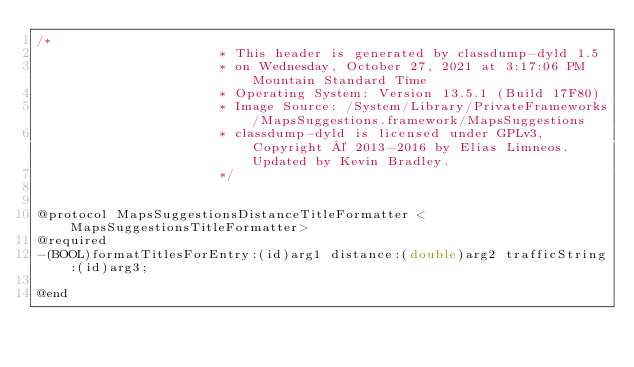Convert code to text. <code><loc_0><loc_0><loc_500><loc_500><_C_>/*
                       * This header is generated by classdump-dyld 1.5
                       * on Wednesday, October 27, 2021 at 3:17:06 PM Mountain Standard Time
                       * Operating System: Version 13.5.1 (Build 17F80)
                       * Image Source: /System/Library/PrivateFrameworks/MapsSuggestions.framework/MapsSuggestions
                       * classdump-dyld is licensed under GPLv3, Copyright © 2013-2016 by Elias Limneos. Updated by Kevin Bradley.
                       */


@protocol MapsSuggestionsDistanceTitleFormatter <MapsSuggestionsTitleFormatter>
@required
-(BOOL)formatTitlesForEntry:(id)arg1 distance:(double)arg2 trafficString:(id)arg3;

@end

</code> 